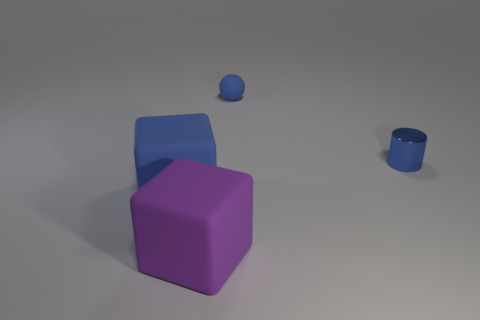How many other objects are the same size as the purple thing?
Make the answer very short. 1. What is the color of the other object that is the same shape as the purple rubber thing?
Provide a succinct answer. Blue. Are there more matte objects that are behind the metal cylinder than big brown things?
Give a very brief answer. Yes. There is a purple rubber object; does it have the same shape as the blue matte object that is in front of the tiny blue cylinder?
Your answer should be very brief. Yes. What is the size of the blue rubber thing that is the same shape as the purple rubber thing?
Provide a short and direct response. Large. Is the number of big blue blocks greater than the number of tiny green metallic cylinders?
Your answer should be compact. Yes. Does the large blue matte object have the same shape as the large purple rubber object?
Offer a very short reply. Yes. There is a purple object in front of the large matte thing to the left of the large purple rubber cube; what is it made of?
Keep it short and to the point. Rubber. There is a large block that is the same color as the small matte thing; what is it made of?
Provide a short and direct response. Rubber. Is the size of the blue metal thing the same as the blue matte ball?
Provide a succinct answer. Yes. 